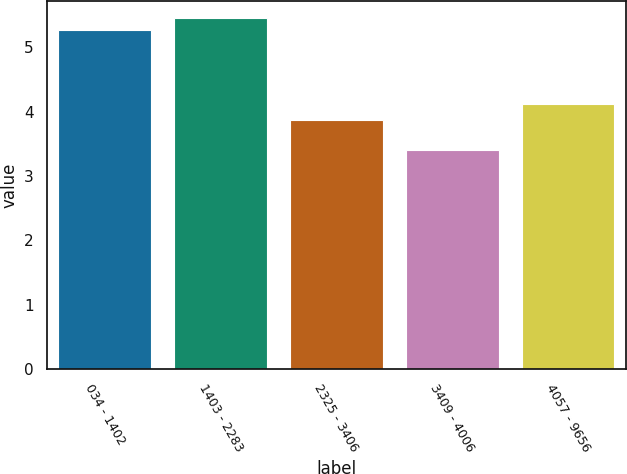Convert chart. <chart><loc_0><loc_0><loc_500><loc_500><bar_chart><fcel>034 - 1402<fcel>1403 - 2283<fcel>2325 - 3406<fcel>3409 - 4006<fcel>4057 - 9656<nl><fcel>5.26<fcel>5.45<fcel>3.87<fcel>3.41<fcel>4.12<nl></chart> 